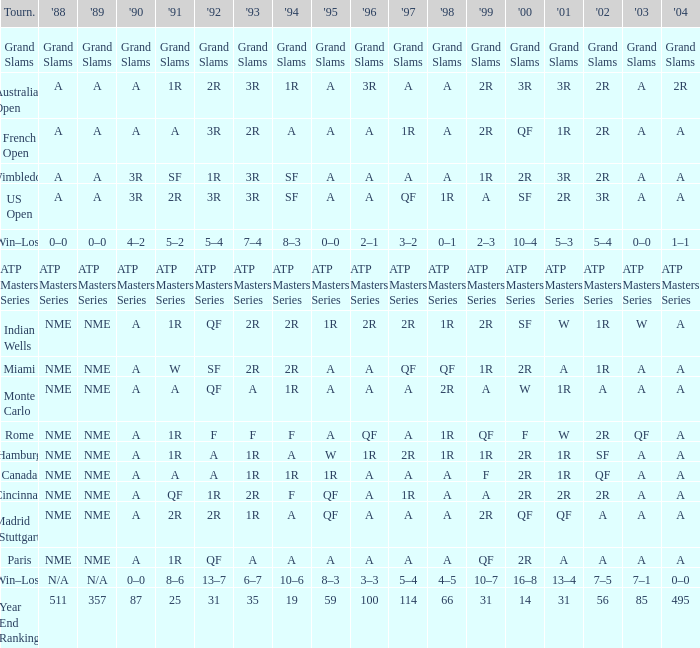What shows for 2002 when the 1991 is w? 1R. 